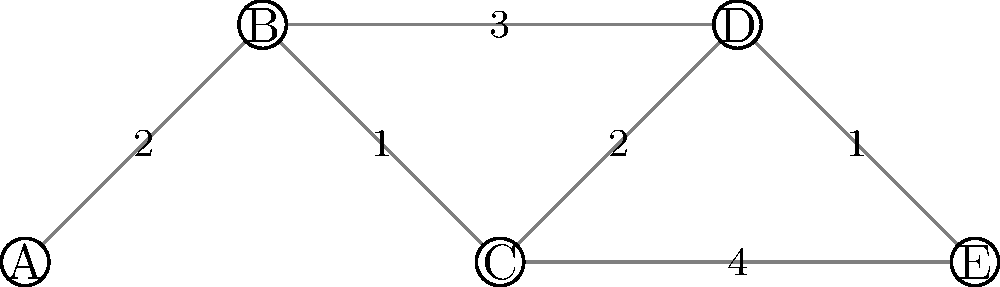As the local councilwoman, you're tasked with evaluating the efficiency of the public transportation network in your district. The network diagram above represents bus routes between five major hubs (A, B, C, D, E) in your area, with edge weights indicating travel time in minutes. What is the minimum total travel time required to visit all hubs, starting and ending at hub A, using the most efficient route? To solve this problem, we need to find the shortest Hamiltonian cycle in the given graph, also known as the Traveling Salesman Problem (TSP). Here's a step-by-step approach:

1. Identify all possible routes starting and ending at A that visit all hubs:
   - A-B-C-D-E-A
   - A-B-C-E-D-A
   - A-B-D-C-E-A
   - A-B-D-E-C-A

2. Calculate the total travel time for each route:

   a) A-B-C-D-E-A:
      $$2 + 1 + 2 + 1 + 4 = 10\text{ minutes}$$

   b) A-B-C-E-D-A:
      $$2 + 1 + 4 + 1 + 3 = 11\text{ minutes}$$

   c) A-B-D-C-E-A:
      $$2 + 3 + 2 + 4 + 4 = 15\text{ minutes}$$

   d) A-B-D-E-C-A:
      $$2 + 3 + 1 + 4 + 1 = 11\text{ minutes}$$

3. Identify the route with the minimum total travel time:
   The route A-B-C-D-E-A has the shortest total travel time of 10 minutes.

Therefore, the minimum total travel time required to visit all hubs, starting and ending at hub A, is 10 minutes.
Answer: 10 minutes 